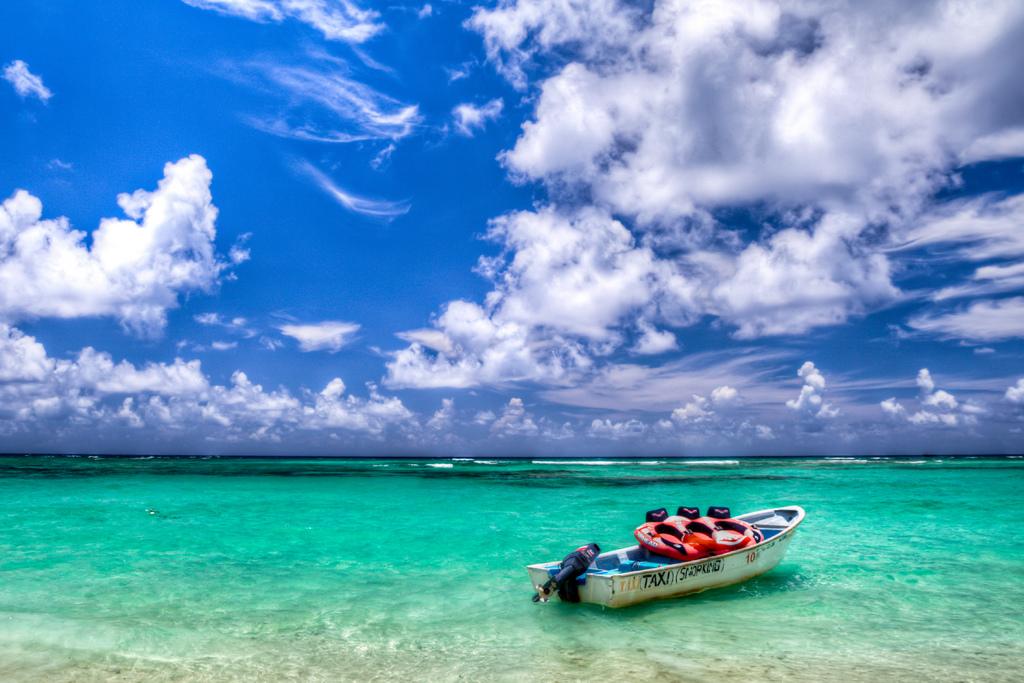Is that a water taxi?
Your answer should be compact. Yes. What's on the side of the boar?
Your answer should be very brief. Taxi. 